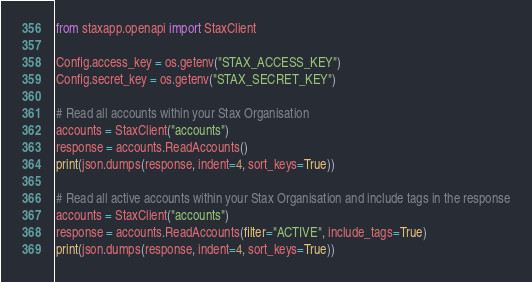Convert code to text. <code><loc_0><loc_0><loc_500><loc_500><_Python_>from staxapp.openapi import StaxClient

Config.access_key = os.getenv("STAX_ACCESS_KEY")
Config.secret_key = os.getenv("STAX_SECRET_KEY")

# Read all accounts within your Stax Organisation
accounts = StaxClient("accounts")
response = accounts.ReadAccounts()
print(json.dumps(response, indent=4, sort_keys=True))

# Read all active accounts within your Stax Organisation and include tags in the response
accounts = StaxClient("accounts")
response = accounts.ReadAccounts(filter="ACTIVE", include_tags=True)
print(json.dumps(response, indent=4, sort_keys=True))
</code> 